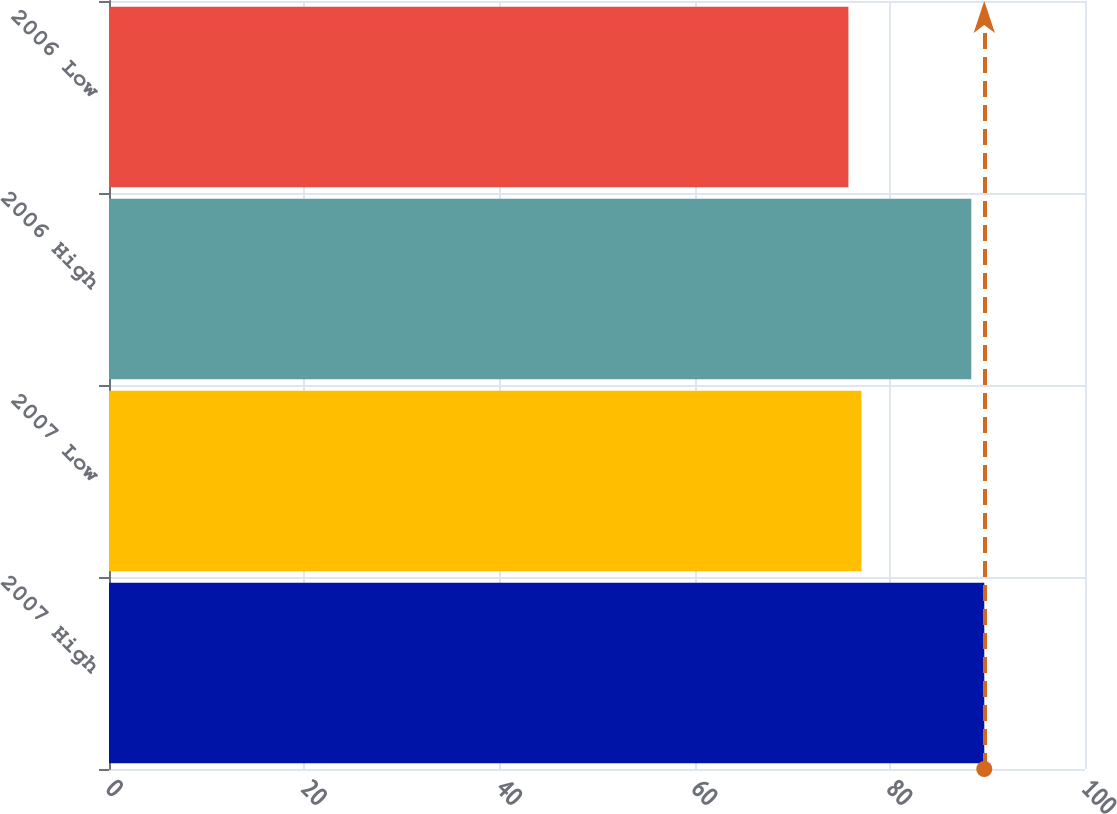<chart> <loc_0><loc_0><loc_500><loc_500><bar_chart><fcel>2007 High<fcel>2007 Low<fcel>2006 High<fcel>2006 Low<nl><fcel>89.68<fcel>77.09<fcel>88.35<fcel>75.76<nl></chart> 